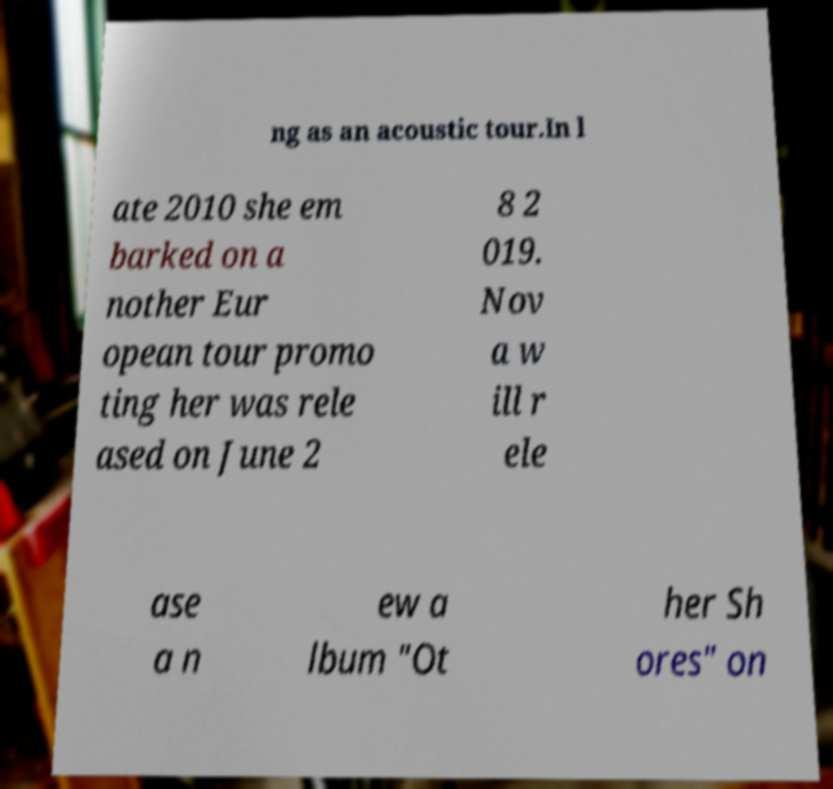For documentation purposes, I need the text within this image transcribed. Could you provide that? ng as an acoustic tour.In l ate 2010 she em barked on a nother Eur opean tour promo ting her was rele ased on June 2 8 2 019. Nov a w ill r ele ase a n ew a lbum "Ot her Sh ores" on 